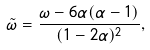Convert formula to latex. <formula><loc_0><loc_0><loc_500><loc_500>\tilde { \omega } = \frac { \omega - 6 \alpha ( \alpha - 1 ) } { ( 1 - 2 \alpha ) ^ { 2 } } ,</formula> 